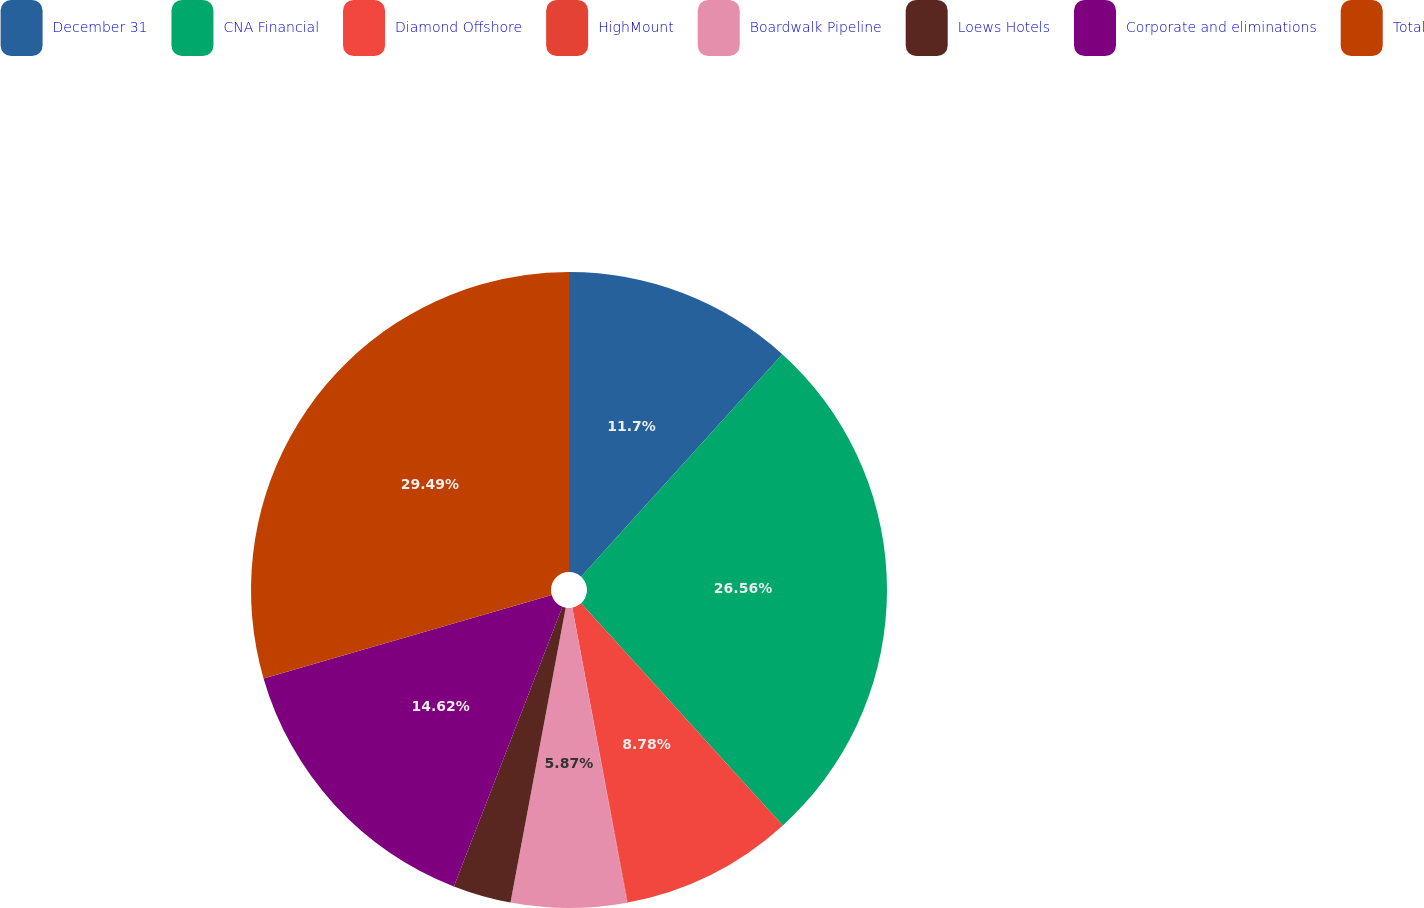Convert chart. <chart><loc_0><loc_0><loc_500><loc_500><pie_chart><fcel>December 31<fcel>CNA Financial<fcel>Diamond Offshore<fcel>HighMount<fcel>Boardwalk Pipeline<fcel>Loews Hotels<fcel>Corporate and eliminations<fcel>Total<nl><fcel>11.7%<fcel>26.56%<fcel>8.78%<fcel>0.03%<fcel>5.87%<fcel>2.95%<fcel>14.62%<fcel>29.48%<nl></chart> 